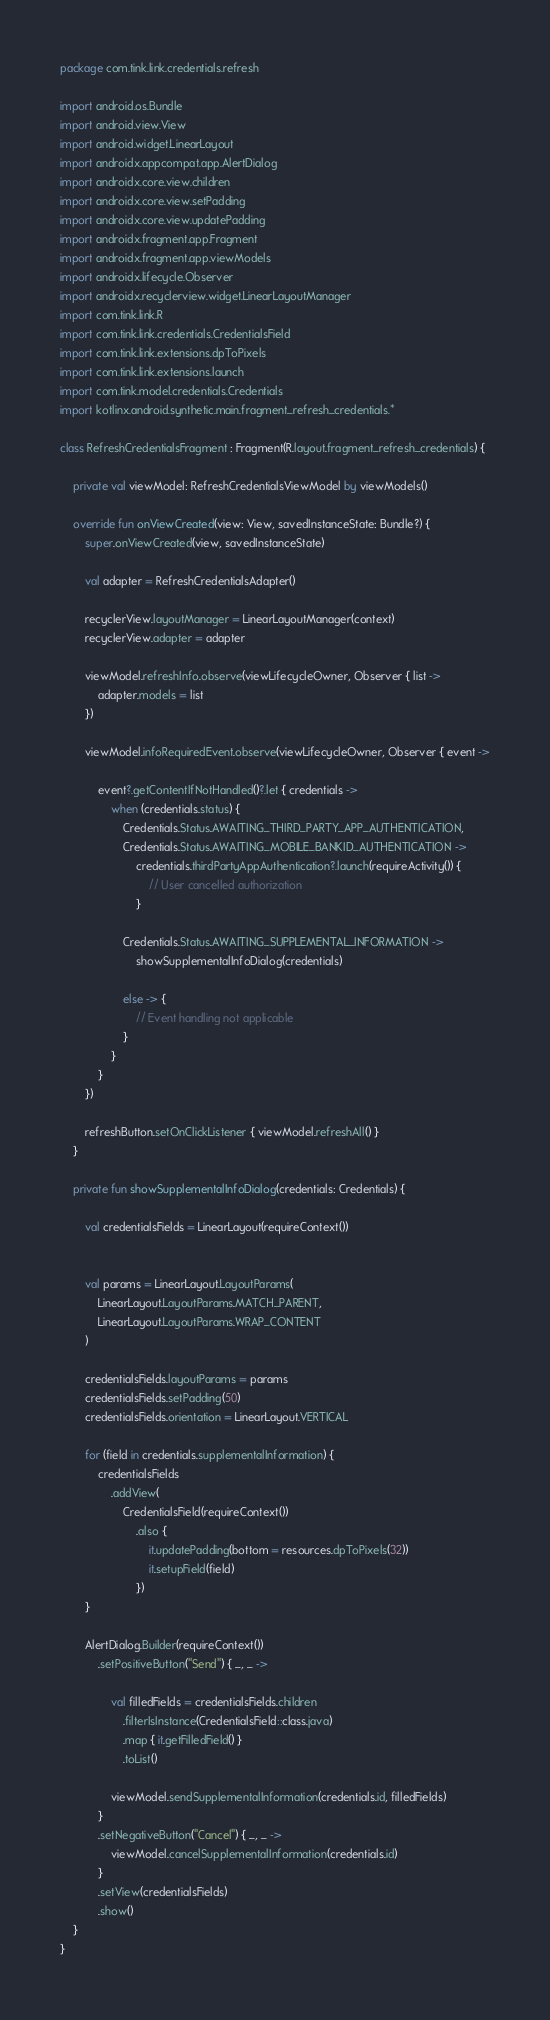<code> <loc_0><loc_0><loc_500><loc_500><_Kotlin_>package com.tink.link.credentials.refresh

import android.os.Bundle
import android.view.View
import android.widget.LinearLayout
import androidx.appcompat.app.AlertDialog
import androidx.core.view.children
import androidx.core.view.setPadding
import androidx.core.view.updatePadding
import androidx.fragment.app.Fragment
import androidx.fragment.app.viewModels
import androidx.lifecycle.Observer
import androidx.recyclerview.widget.LinearLayoutManager
import com.tink.link.R
import com.tink.link.credentials.CredentialsField
import com.tink.link.extensions.dpToPixels
import com.tink.link.extensions.launch
import com.tink.model.credentials.Credentials
import kotlinx.android.synthetic.main.fragment_refresh_credentials.*

class RefreshCredentialsFragment : Fragment(R.layout.fragment_refresh_credentials) {

    private val viewModel: RefreshCredentialsViewModel by viewModels()

    override fun onViewCreated(view: View, savedInstanceState: Bundle?) {
        super.onViewCreated(view, savedInstanceState)

        val adapter = RefreshCredentialsAdapter()

        recyclerView.layoutManager = LinearLayoutManager(context)
        recyclerView.adapter = adapter

        viewModel.refreshInfo.observe(viewLifecycleOwner, Observer { list ->
            adapter.models = list
        })

        viewModel.infoRequiredEvent.observe(viewLifecycleOwner, Observer { event ->

            event?.getContentIfNotHandled()?.let { credentials ->
                when (credentials.status) {
                    Credentials.Status.AWAITING_THIRD_PARTY_APP_AUTHENTICATION,
                    Credentials.Status.AWAITING_MOBILE_BANKID_AUTHENTICATION ->
                        credentials.thirdPartyAppAuthentication?.launch(requireActivity()) {
                            // User cancelled authorization
                        }

                    Credentials.Status.AWAITING_SUPPLEMENTAL_INFORMATION ->
                        showSupplementalInfoDialog(credentials)

                    else -> {
                        // Event handling not applicable
                    }
                }
            }
        })

        refreshButton.setOnClickListener { viewModel.refreshAll() }
    }

    private fun showSupplementalInfoDialog(credentials: Credentials) {

        val credentialsFields = LinearLayout(requireContext())


        val params = LinearLayout.LayoutParams(
            LinearLayout.LayoutParams.MATCH_PARENT,
            LinearLayout.LayoutParams.WRAP_CONTENT
        )

        credentialsFields.layoutParams = params
        credentialsFields.setPadding(50)
        credentialsFields.orientation = LinearLayout.VERTICAL

        for (field in credentials.supplementalInformation) {
            credentialsFields
                .addView(
                    CredentialsField(requireContext())
                        .also {
                            it.updatePadding(bottom = resources.dpToPixels(32))
                            it.setupField(field)
                        })
        }

        AlertDialog.Builder(requireContext())
            .setPositiveButton("Send") { _, _ ->

                val filledFields = credentialsFields.children
                    .filterIsInstance(CredentialsField::class.java)
                    .map { it.getFilledField() }
                    .toList()

                viewModel.sendSupplementalInformation(credentials.id, filledFields)
            }
            .setNegativeButton("Cancel") { _, _ ->
                viewModel.cancelSupplementalInformation(credentials.id)
            }
            .setView(credentialsFields)
            .show()
    }
}
</code> 